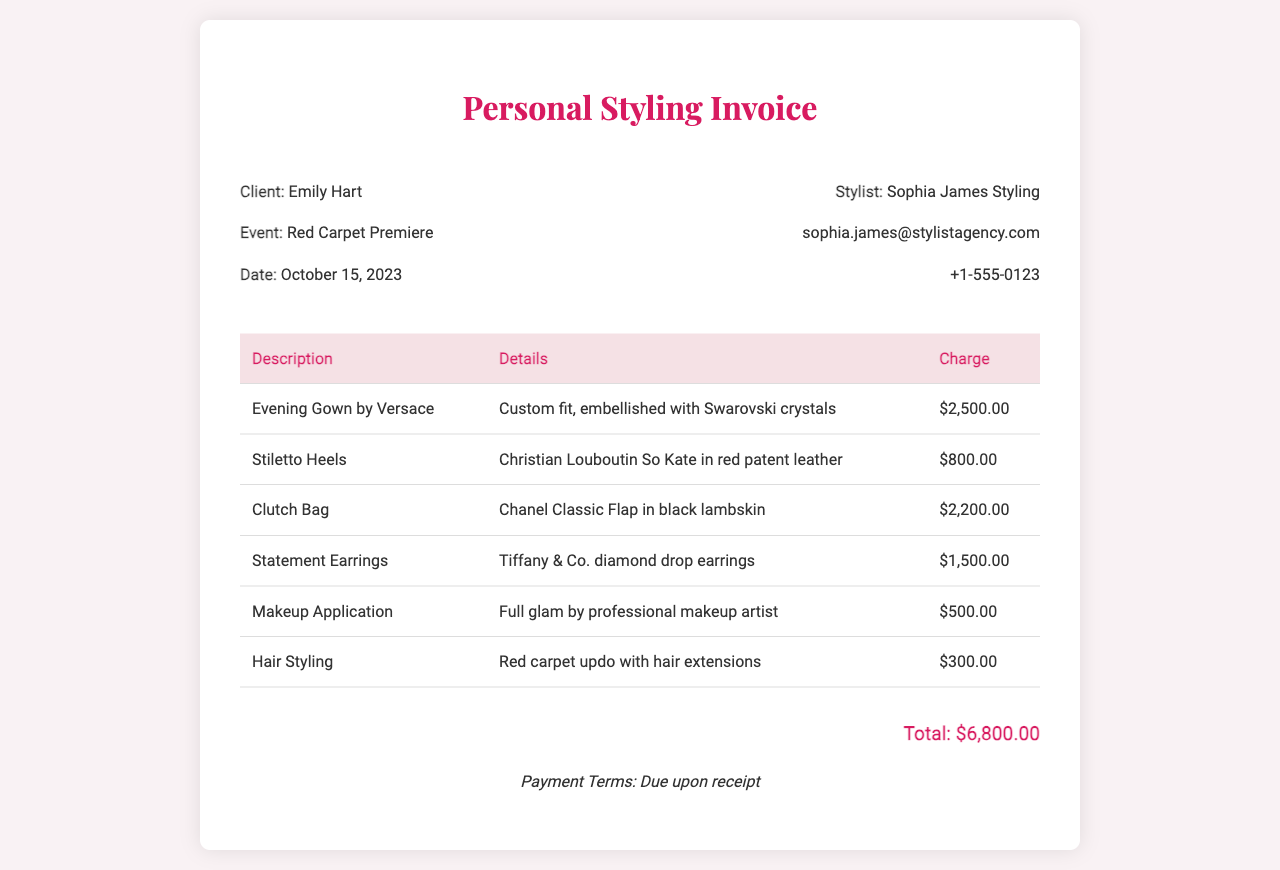What is the total charge? The total charge is listed at the bottom of the invoice, summing all individual charges.
Answer: $6,800.00 Who is the stylist? The stylist's name is mentioned in the header section of the invoice.
Answer: Sophia James Styling What date is the event? The date of the event is specified in the client information section.
Answer: October 15, 2023 How much was charged for the Evening Gown? The individual charge for the Evening Gown can be found in the table with the detailed charges.
Answer: $2,500.00 What type of makeup service was provided? The description of the makeup service is included in the table under Makeup Application.
Answer: Full glam by professional makeup artist How much did the Statement Earrings cost? The cost of the Statement Earrings is specifically stated in the charge table.
Answer: $1,500.00 What payment terms are indicated? The payment terms are outlined at the bottom of the invoice.
Answer: Due upon receipt Which accessory is the most expensive? The most expensive accessory can be determined by comparing the prices listed in the table.
Answer: Clutch Bag Was hair styling included in the services? The document lists hair styling as one of the chargeable services in the invoice.
Answer: Yes 